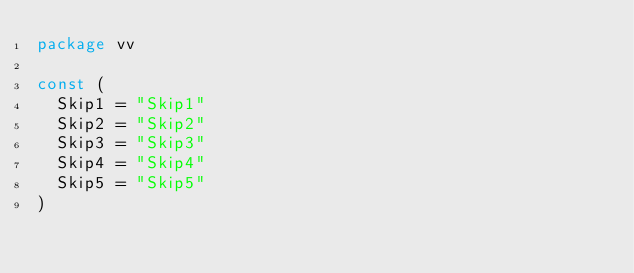<code> <loc_0><loc_0><loc_500><loc_500><_Go_>package vv

const (
	Skip1 = "Skip1"
	Skip2 = "Skip2"
	Skip3 = "Skip3"
	Skip4 = "Skip4"
	Skip5 = "Skip5"
)
</code> 